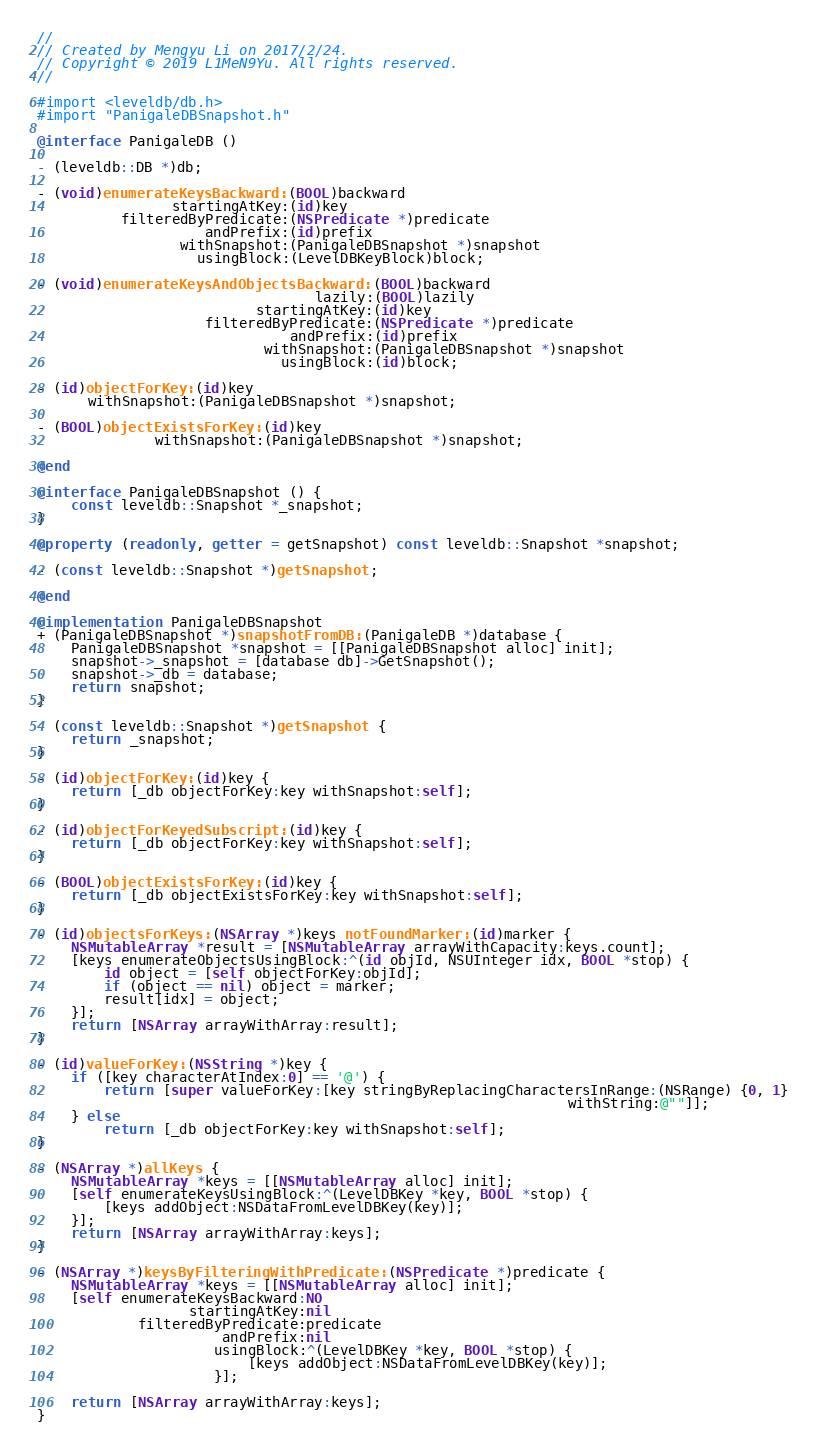Convert code to text. <code><loc_0><loc_0><loc_500><loc_500><_ObjectiveC_>//
// Created by Mengyu Li on 2017/2/24.
// Copyright © 2019 L1MeN9Yu. All rights reserved.
//

#import <leveldb/db.h>
#import "PanigaleDBSnapshot.h"

@interface PanigaleDB ()

- (leveldb::DB *)db;

- (void)enumerateKeysBackward:(BOOL)backward
                startingAtKey:(id)key
          filteredByPredicate:(NSPredicate *)predicate
                    andPrefix:(id)prefix
                 withSnapshot:(PanigaleDBSnapshot *)snapshot
                   usingBlock:(LevelDBKeyBlock)block;

- (void)enumerateKeysAndObjectsBackward:(BOOL)backward
                                 lazily:(BOOL)lazily
                          startingAtKey:(id)key
                    filteredByPredicate:(NSPredicate *)predicate
                              andPrefix:(id)prefix
                           withSnapshot:(PanigaleDBSnapshot *)snapshot
                             usingBlock:(id)block;

- (id)objectForKey:(id)key
      withSnapshot:(PanigaleDBSnapshot *)snapshot;

- (BOOL)objectExistsForKey:(id)key
              withSnapshot:(PanigaleDBSnapshot *)snapshot;

@end

@interface PanigaleDBSnapshot () {
    const leveldb::Snapshot *_snapshot;
}

@property (readonly, getter = getSnapshot) const leveldb::Snapshot *snapshot;

- (const leveldb::Snapshot *)getSnapshot;

@end

@implementation PanigaleDBSnapshot
+ (PanigaleDBSnapshot *)snapshotFromDB:(PanigaleDB *)database {
    PanigaleDBSnapshot *snapshot = [[PanigaleDBSnapshot alloc] init];
    snapshot->_snapshot = [database db]->GetSnapshot();
    snapshot->_db = database;
    return snapshot;
}

- (const leveldb::Snapshot *)getSnapshot {
    return _snapshot;
}

- (id)objectForKey:(id)key {
    return [_db objectForKey:key withSnapshot:self];
}

- (id)objectForKeyedSubscript:(id)key {
    return [_db objectForKey:key withSnapshot:self];
}

- (BOOL)objectExistsForKey:(id)key {
    return [_db objectExistsForKey:key withSnapshot:self];
}

- (id)objectsForKeys:(NSArray *)keys notFoundMarker:(id)marker {
    NSMutableArray *result = [NSMutableArray arrayWithCapacity:keys.count];
    [keys enumerateObjectsUsingBlock:^(id objId, NSUInteger idx, BOOL *stop) {
        id object = [self objectForKey:objId];
        if (object == nil) object = marker;
        result[idx] = object;
    }];
    return [NSArray arrayWithArray:result];
}

- (id)valueForKey:(NSString *)key {
    if ([key characterAtIndex:0] == '@') {
        return [super valueForKey:[key stringByReplacingCharactersInRange:(NSRange) {0, 1}
                                                               withString:@""]];
    } else
        return [_db objectForKey:key withSnapshot:self];
}

- (NSArray *)allKeys {
    NSMutableArray *keys = [[NSMutableArray alloc] init];
    [self enumerateKeysUsingBlock:^(LevelDBKey *key, BOOL *stop) {
        [keys addObject:NSDataFromLevelDBKey(key)];
    }];
    return [NSArray arrayWithArray:keys];
}

- (NSArray *)keysByFilteringWithPredicate:(NSPredicate *)predicate {
    NSMutableArray *keys = [[NSMutableArray alloc] init];
    [self enumerateKeysBackward:NO
                  startingAtKey:nil
            filteredByPredicate:predicate
                      andPrefix:nil
                     usingBlock:^(LevelDBKey *key, BOOL *stop) {
                         [keys addObject:NSDataFromLevelDBKey(key)];
                     }];

    return [NSArray arrayWithArray:keys];
}
</code> 